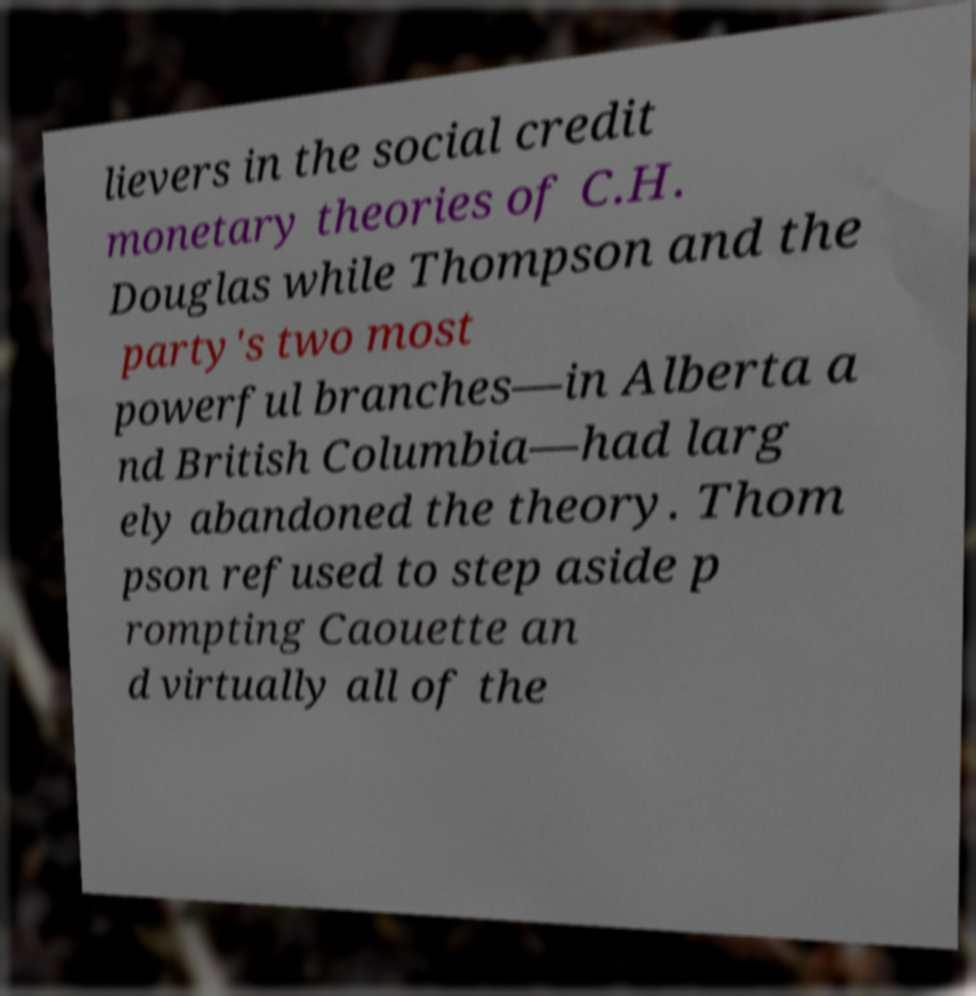Please read and relay the text visible in this image. What does it say? lievers in the social credit monetary theories of C.H. Douglas while Thompson and the party's two most powerful branches—in Alberta a nd British Columbia—had larg ely abandoned the theory. Thom pson refused to step aside p rompting Caouette an d virtually all of the 